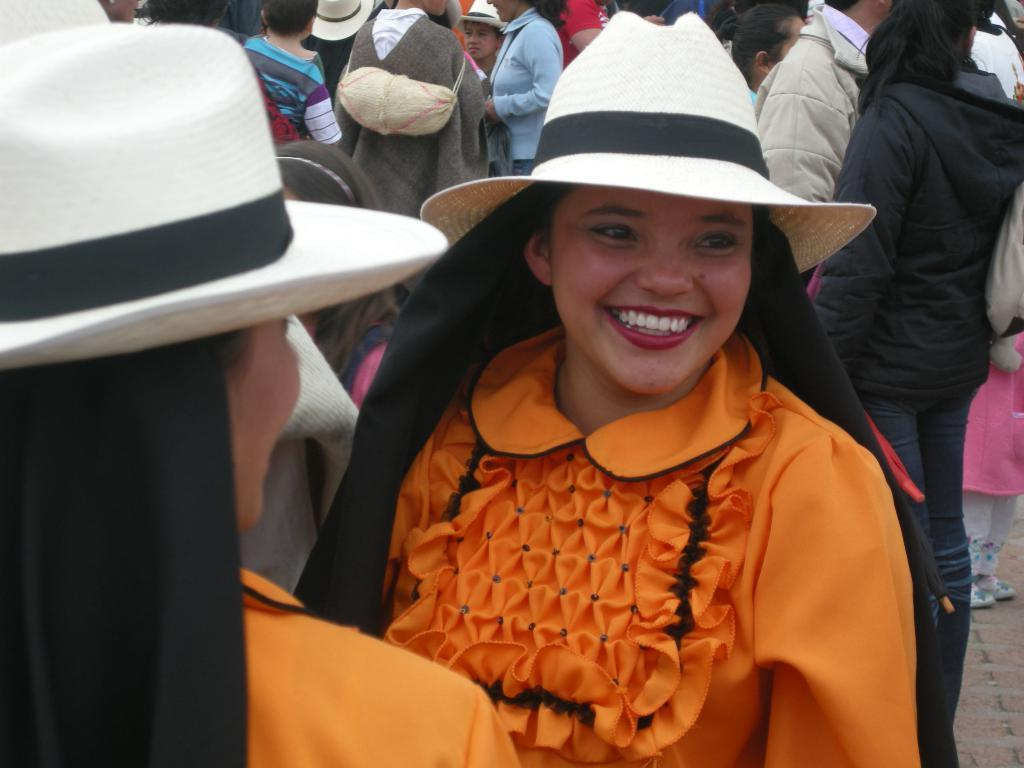What is happening in the image? There are people standing in the image. Can you describe the facial expression of the woman in the front? The woman in the front is smiling. Are there any accessories or clothing items that stand out in the image? Two persons in the image are wearing caps. What type of corn can be seen growing in the background of the image? There is no corn visible in the image; it features people standing and wearing caps. 